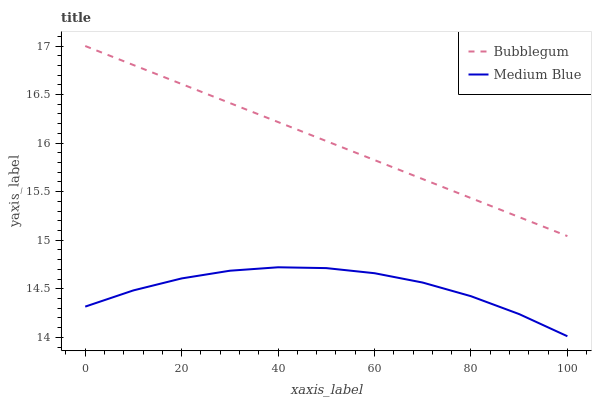Does Medium Blue have the minimum area under the curve?
Answer yes or no. Yes. Does Bubblegum have the maximum area under the curve?
Answer yes or no. Yes. Does Bubblegum have the minimum area under the curve?
Answer yes or no. No. Is Bubblegum the smoothest?
Answer yes or no. Yes. Is Medium Blue the roughest?
Answer yes or no. Yes. Is Bubblegum the roughest?
Answer yes or no. No. Does Bubblegum have the lowest value?
Answer yes or no. No. Is Medium Blue less than Bubblegum?
Answer yes or no. Yes. Is Bubblegum greater than Medium Blue?
Answer yes or no. Yes. Does Medium Blue intersect Bubblegum?
Answer yes or no. No. 